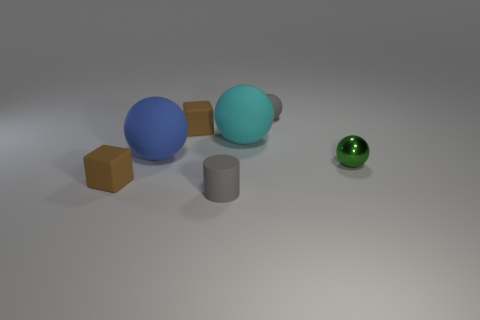Add 2 tiny green shiny balls. How many objects exist? 9 Subtract all small gray balls. How many balls are left? 3 Subtract 2 cubes. How many cubes are left? 0 Subtract all blue balls. How many balls are left? 3 Subtract all spheres. How many objects are left? 3 Add 7 large cyan things. How many large cyan things exist? 8 Subtract 0 yellow blocks. How many objects are left? 7 Subtract all purple cubes. Subtract all red spheres. How many cubes are left? 2 Subtract all large gray metallic objects. Subtract all matte things. How many objects are left? 1 Add 7 gray cylinders. How many gray cylinders are left? 8 